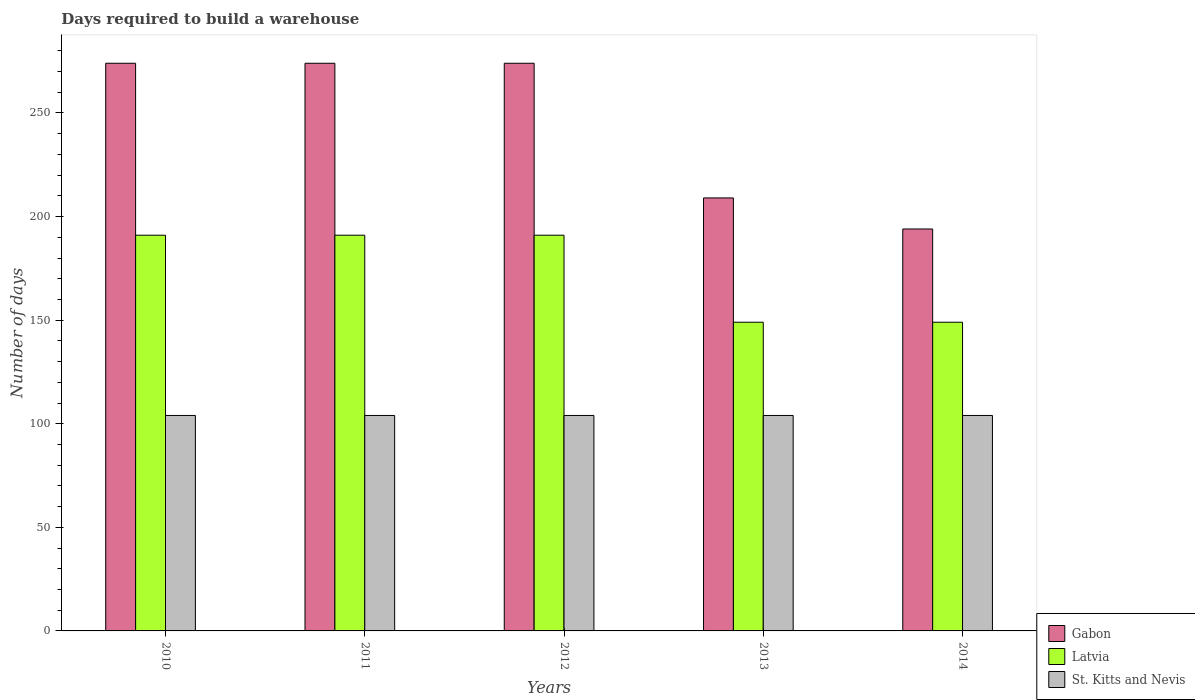How many groups of bars are there?
Your answer should be very brief. 5. Are the number of bars on each tick of the X-axis equal?
Ensure brevity in your answer.  Yes. In how many cases, is the number of bars for a given year not equal to the number of legend labels?
Your response must be concise. 0. What is the days required to build a warehouse in in St. Kitts and Nevis in 2014?
Make the answer very short. 104. Across all years, what is the maximum days required to build a warehouse in in Latvia?
Your response must be concise. 191. Across all years, what is the minimum days required to build a warehouse in in Latvia?
Make the answer very short. 149. In which year was the days required to build a warehouse in in St. Kitts and Nevis maximum?
Your answer should be compact. 2010. In which year was the days required to build a warehouse in in St. Kitts and Nevis minimum?
Your answer should be compact. 2010. What is the total days required to build a warehouse in in Latvia in the graph?
Offer a very short reply. 871. What is the difference between the days required to build a warehouse in in Latvia in 2014 and the days required to build a warehouse in in St. Kitts and Nevis in 2012?
Provide a short and direct response. 45. What is the average days required to build a warehouse in in Latvia per year?
Provide a short and direct response. 174.2. In the year 2013, what is the difference between the days required to build a warehouse in in St. Kitts and Nevis and days required to build a warehouse in in Latvia?
Provide a succinct answer. -45. In how many years, is the days required to build a warehouse in in Gabon greater than 130 days?
Offer a very short reply. 5. What is the ratio of the days required to build a warehouse in in St. Kitts and Nevis in 2011 to that in 2013?
Provide a succinct answer. 1. Is the days required to build a warehouse in in Latvia in 2012 less than that in 2014?
Make the answer very short. No. Is the difference between the days required to build a warehouse in in St. Kitts and Nevis in 2012 and 2014 greater than the difference between the days required to build a warehouse in in Latvia in 2012 and 2014?
Give a very brief answer. No. What is the difference between the highest and the second highest days required to build a warehouse in in Gabon?
Offer a very short reply. 0. What is the difference between the highest and the lowest days required to build a warehouse in in Gabon?
Offer a very short reply. 80. What does the 1st bar from the left in 2013 represents?
Make the answer very short. Gabon. What does the 1st bar from the right in 2011 represents?
Your answer should be very brief. St. Kitts and Nevis. Is it the case that in every year, the sum of the days required to build a warehouse in in Gabon and days required to build a warehouse in in Latvia is greater than the days required to build a warehouse in in St. Kitts and Nevis?
Offer a terse response. Yes. How many bars are there?
Offer a very short reply. 15. Are all the bars in the graph horizontal?
Make the answer very short. No. How many years are there in the graph?
Give a very brief answer. 5. Are the values on the major ticks of Y-axis written in scientific E-notation?
Make the answer very short. No. Does the graph contain any zero values?
Keep it short and to the point. No. Does the graph contain grids?
Make the answer very short. No. Where does the legend appear in the graph?
Provide a succinct answer. Bottom right. What is the title of the graph?
Provide a succinct answer. Days required to build a warehouse. What is the label or title of the Y-axis?
Keep it short and to the point. Number of days. What is the Number of days in Gabon in 2010?
Make the answer very short. 274. What is the Number of days in Latvia in 2010?
Make the answer very short. 191. What is the Number of days of St. Kitts and Nevis in 2010?
Give a very brief answer. 104. What is the Number of days in Gabon in 2011?
Offer a very short reply. 274. What is the Number of days of Latvia in 2011?
Your response must be concise. 191. What is the Number of days of St. Kitts and Nevis in 2011?
Give a very brief answer. 104. What is the Number of days in Gabon in 2012?
Your response must be concise. 274. What is the Number of days in Latvia in 2012?
Make the answer very short. 191. What is the Number of days in St. Kitts and Nevis in 2012?
Ensure brevity in your answer.  104. What is the Number of days of Gabon in 2013?
Keep it short and to the point. 209. What is the Number of days of Latvia in 2013?
Keep it short and to the point. 149. What is the Number of days in St. Kitts and Nevis in 2013?
Give a very brief answer. 104. What is the Number of days of Gabon in 2014?
Give a very brief answer. 194. What is the Number of days of Latvia in 2014?
Give a very brief answer. 149. What is the Number of days of St. Kitts and Nevis in 2014?
Ensure brevity in your answer.  104. Across all years, what is the maximum Number of days in Gabon?
Ensure brevity in your answer.  274. Across all years, what is the maximum Number of days of Latvia?
Your response must be concise. 191. Across all years, what is the maximum Number of days of St. Kitts and Nevis?
Provide a short and direct response. 104. Across all years, what is the minimum Number of days of Gabon?
Your response must be concise. 194. Across all years, what is the minimum Number of days in Latvia?
Ensure brevity in your answer.  149. Across all years, what is the minimum Number of days of St. Kitts and Nevis?
Your answer should be very brief. 104. What is the total Number of days in Gabon in the graph?
Keep it short and to the point. 1225. What is the total Number of days in Latvia in the graph?
Ensure brevity in your answer.  871. What is the total Number of days of St. Kitts and Nevis in the graph?
Your response must be concise. 520. What is the difference between the Number of days of Gabon in 2010 and that in 2011?
Your answer should be compact. 0. What is the difference between the Number of days of St. Kitts and Nevis in 2010 and that in 2012?
Provide a succinct answer. 0. What is the difference between the Number of days in Gabon in 2010 and that in 2013?
Provide a succinct answer. 65. What is the difference between the Number of days of Latvia in 2010 and that in 2013?
Provide a succinct answer. 42. What is the difference between the Number of days of St. Kitts and Nevis in 2010 and that in 2013?
Offer a terse response. 0. What is the difference between the Number of days in Latvia in 2010 and that in 2014?
Offer a terse response. 42. What is the difference between the Number of days of St. Kitts and Nevis in 2010 and that in 2014?
Your response must be concise. 0. What is the difference between the Number of days in Latvia in 2011 and that in 2012?
Your answer should be compact. 0. What is the difference between the Number of days in Latvia in 2011 and that in 2013?
Keep it short and to the point. 42. What is the difference between the Number of days of St. Kitts and Nevis in 2011 and that in 2013?
Your answer should be very brief. 0. What is the difference between the Number of days of Latvia in 2011 and that in 2014?
Provide a short and direct response. 42. What is the difference between the Number of days of St. Kitts and Nevis in 2011 and that in 2014?
Your answer should be very brief. 0. What is the difference between the Number of days of Latvia in 2012 and that in 2013?
Offer a terse response. 42. What is the difference between the Number of days in Gabon in 2013 and that in 2014?
Your response must be concise. 15. What is the difference between the Number of days in Latvia in 2013 and that in 2014?
Ensure brevity in your answer.  0. What is the difference between the Number of days of St. Kitts and Nevis in 2013 and that in 2014?
Your answer should be very brief. 0. What is the difference between the Number of days in Gabon in 2010 and the Number of days in Latvia in 2011?
Make the answer very short. 83. What is the difference between the Number of days in Gabon in 2010 and the Number of days in St. Kitts and Nevis in 2011?
Provide a short and direct response. 170. What is the difference between the Number of days in Gabon in 2010 and the Number of days in St. Kitts and Nevis in 2012?
Provide a short and direct response. 170. What is the difference between the Number of days in Latvia in 2010 and the Number of days in St. Kitts and Nevis in 2012?
Your response must be concise. 87. What is the difference between the Number of days of Gabon in 2010 and the Number of days of Latvia in 2013?
Ensure brevity in your answer.  125. What is the difference between the Number of days in Gabon in 2010 and the Number of days in St. Kitts and Nevis in 2013?
Offer a very short reply. 170. What is the difference between the Number of days in Latvia in 2010 and the Number of days in St. Kitts and Nevis in 2013?
Offer a terse response. 87. What is the difference between the Number of days in Gabon in 2010 and the Number of days in Latvia in 2014?
Keep it short and to the point. 125. What is the difference between the Number of days in Gabon in 2010 and the Number of days in St. Kitts and Nevis in 2014?
Offer a terse response. 170. What is the difference between the Number of days of Gabon in 2011 and the Number of days of St. Kitts and Nevis in 2012?
Provide a short and direct response. 170. What is the difference between the Number of days in Gabon in 2011 and the Number of days in Latvia in 2013?
Your answer should be compact. 125. What is the difference between the Number of days of Gabon in 2011 and the Number of days of St. Kitts and Nevis in 2013?
Your response must be concise. 170. What is the difference between the Number of days of Latvia in 2011 and the Number of days of St. Kitts and Nevis in 2013?
Offer a terse response. 87. What is the difference between the Number of days of Gabon in 2011 and the Number of days of Latvia in 2014?
Your answer should be compact. 125. What is the difference between the Number of days in Gabon in 2011 and the Number of days in St. Kitts and Nevis in 2014?
Make the answer very short. 170. What is the difference between the Number of days of Gabon in 2012 and the Number of days of Latvia in 2013?
Your answer should be very brief. 125. What is the difference between the Number of days of Gabon in 2012 and the Number of days of St. Kitts and Nevis in 2013?
Keep it short and to the point. 170. What is the difference between the Number of days in Gabon in 2012 and the Number of days in Latvia in 2014?
Keep it short and to the point. 125. What is the difference between the Number of days of Gabon in 2012 and the Number of days of St. Kitts and Nevis in 2014?
Your answer should be compact. 170. What is the difference between the Number of days in Gabon in 2013 and the Number of days in St. Kitts and Nevis in 2014?
Your answer should be compact. 105. What is the difference between the Number of days in Latvia in 2013 and the Number of days in St. Kitts and Nevis in 2014?
Ensure brevity in your answer.  45. What is the average Number of days of Gabon per year?
Your response must be concise. 245. What is the average Number of days in Latvia per year?
Offer a terse response. 174.2. What is the average Number of days in St. Kitts and Nevis per year?
Make the answer very short. 104. In the year 2010, what is the difference between the Number of days of Gabon and Number of days of Latvia?
Keep it short and to the point. 83. In the year 2010, what is the difference between the Number of days of Gabon and Number of days of St. Kitts and Nevis?
Give a very brief answer. 170. In the year 2010, what is the difference between the Number of days of Latvia and Number of days of St. Kitts and Nevis?
Make the answer very short. 87. In the year 2011, what is the difference between the Number of days of Gabon and Number of days of St. Kitts and Nevis?
Ensure brevity in your answer.  170. In the year 2012, what is the difference between the Number of days of Gabon and Number of days of Latvia?
Your response must be concise. 83. In the year 2012, what is the difference between the Number of days of Gabon and Number of days of St. Kitts and Nevis?
Your answer should be very brief. 170. In the year 2012, what is the difference between the Number of days of Latvia and Number of days of St. Kitts and Nevis?
Your response must be concise. 87. In the year 2013, what is the difference between the Number of days of Gabon and Number of days of St. Kitts and Nevis?
Offer a very short reply. 105. In the year 2014, what is the difference between the Number of days in Latvia and Number of days in St. Kitts and Nevis?
Offer a terse response. 45. What is the ratio of the Number of days in Gabon in 2010 to that in 2011?
Your response must be concise. 1. What is the ratio of the Number of days in St. Kitts and Nevis in 2010 to that in 2011?
Offer a very short reply. 1. What is the ratio of the Number of days of Gabon in 2010 to that in 2012?
Keep it short and to the point. 1. What is the ratio of the Number of days of Latvia in 2010 to that in 2012?
Your answer should be very brief. 1. What is the ratio of the Number of days of St. Kitts and Nevis in 2010 to that in 2012?
Give a very brief answer. 1. What is the ratio of the Number of days in Gabon in 2010 to that in 2013?
Your response must be concise. 1.31. What is the ratio of the Number of days of Latvia in 2010 to that in 2013?
Make the answer very short. 1.28. What is the ratio of the Number of days in Gabon in 2010 to that in 2014?
Provide a succinct answer. 1.41. What is the ratio of the Number of days of Latvia in 2010 to that in 2014?
Your answer should be very brief. 1.28. What is the ratio of the Number of days of Latvia in 2011 to that in 2012?
Offer a very short reply. 1. What is the ratio of the Number of days of Gabon in 2011 to that in 2013?
Your answer should be very brief. 1.31. What is the ratio of the Number of days in Latvia in 2011 to that in 2013?
Ensure brevity in your answer.  1.28. What is the ratio of the Number of days in Gabon in 2011 to that in 2014?
Offer a terse response. 1.41. What is the ratio of the Number of days in Latvia in 2011 to that in 2014?
Offer a terse response. 1.28. What is the ratio of the Number of days of Gabon in 2012 to that in 2013?
Offer a very short reply. 1.31. What is the ratio of the Number of days of Latvia in 2012 to that in 2013?
Offer a terse response. 1.28. What is the ratio of the Number of days in Gabon in 2012 to that in 2014?
Your answer should be compact. 1.41. What is the ratio of the Number of days in Latvia in 2012 to that in 2014?
Your answer should be compact. 1.28. What is the ratio of the Number of days of St. Kitts and Nevis in 2012 to that in 2014?
Your response must be concise. 1. What is the ratio of the Number of days in Gabon in 2013 to that in 2014?
Provide a succinct answer. 1.08. What is the ratio of the Number of days of St. Kitts and Nevis in 2013 to that in 2014?
Ensure brevity in your answer.  1. What is the difference between the highest and the lowest Number of days of Gabon?
Keep it short and to the point. 80. 